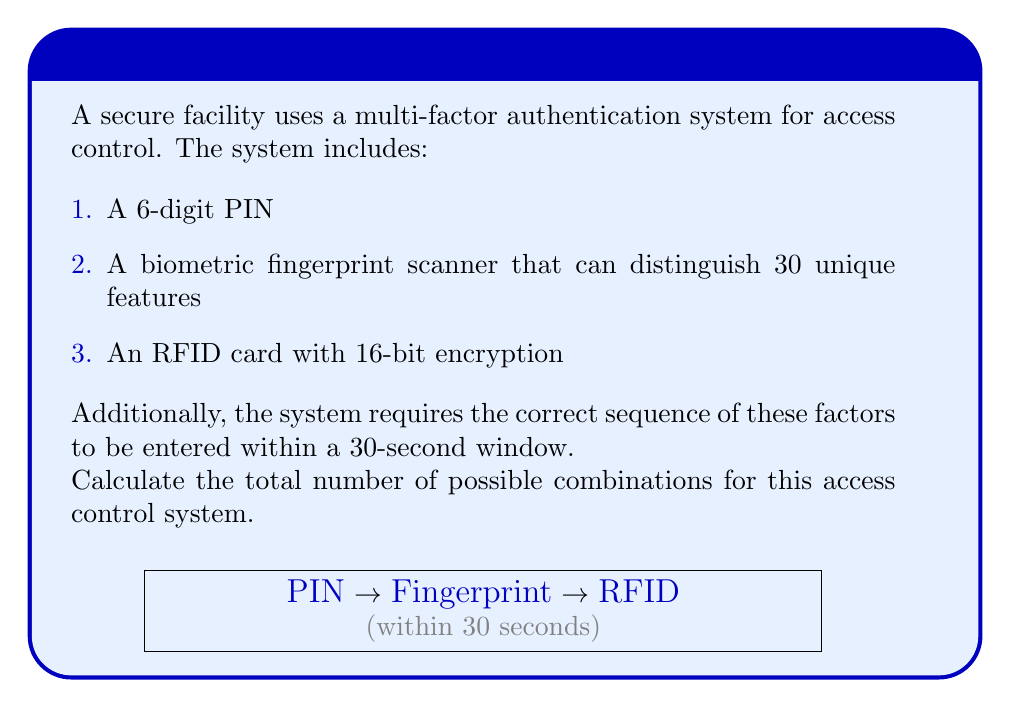Provide a solution to this math problem. Let's break this down step-by-step:

1. 6-digit PIN:
   There are 10 possible digits (0-9) for each of the 6 positions.
   Number of PIN combinations = $10^6$

2. Biometric fingerprint scanner:
   The scanner can distinguish 30 unique features.
   Number of fingerprint combinations = 30

3. RFID card with 16-bit encryption:
   With 16 bits, there are $2^{16}$ possible combinations.

4. Sequence of factors:
   There are 3! = 6 possible sequences for entering the three factors.

5. Time constraint:
   The 30-second window doesn't affect the number of combinations, so we don't need to factor this in.

To calculate the total number of combinations, we multiply all these factors together:

$$ \text{Total combinations} = 10^6 \times 30 \times 2^{16} \times 6 $$

$$ = 1,000,000 \times 30 \times 65,536 \times 6 $$

$$ = 11,796,480,000,000 $$

This can also be written as $1.1796480 \times 10^{13}$
Answer: $1.1796480 \times 10^{13}$ 